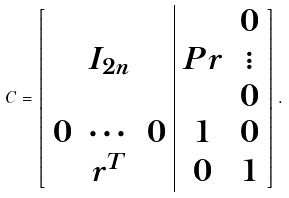<formula> <loc_0><loc_0><loc_500><loc_500>C = \left [ \begin{array} { c c c | c c } & & & & 0 \\ & I _ { 2 n } & & P r & \vdots \\ & & & & 0 \\ 0 & \cdots & 0 & 1 & 0 \\ & r ^ { T } & & 0 & 1 \end{array} \right ] .</formula> 